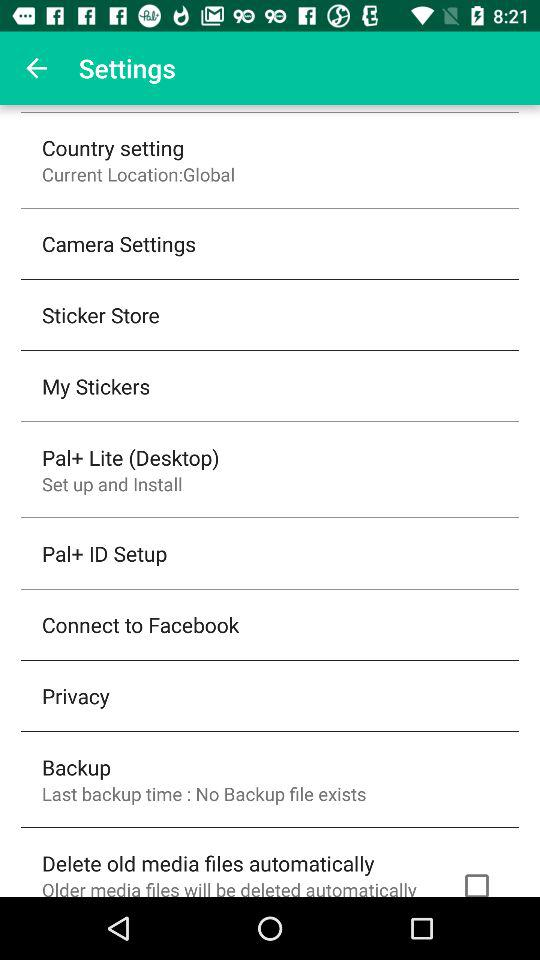What location is selected as the current location? The location that is selected as the current location is "Global". 